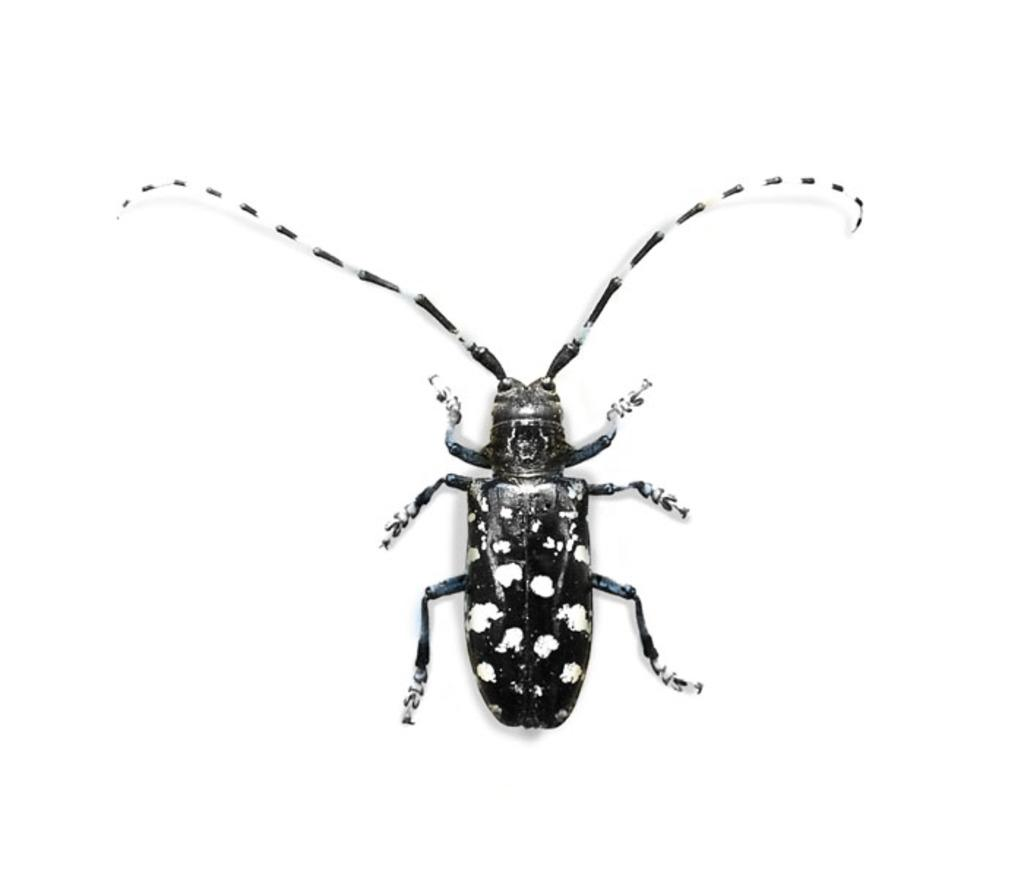What type of creature can be seen in the image? There is an insect in the image. What is the color of the insect? The insect is black in color. What is the background of the image? The background of the image is white. What type of cake is being served in the image? There is no cake present in the image; it features an insect on a white background. What type of pan is used to cook the insect in the image? There is no pan or cooking involved in the image; it simply shows an insect on a white background. 